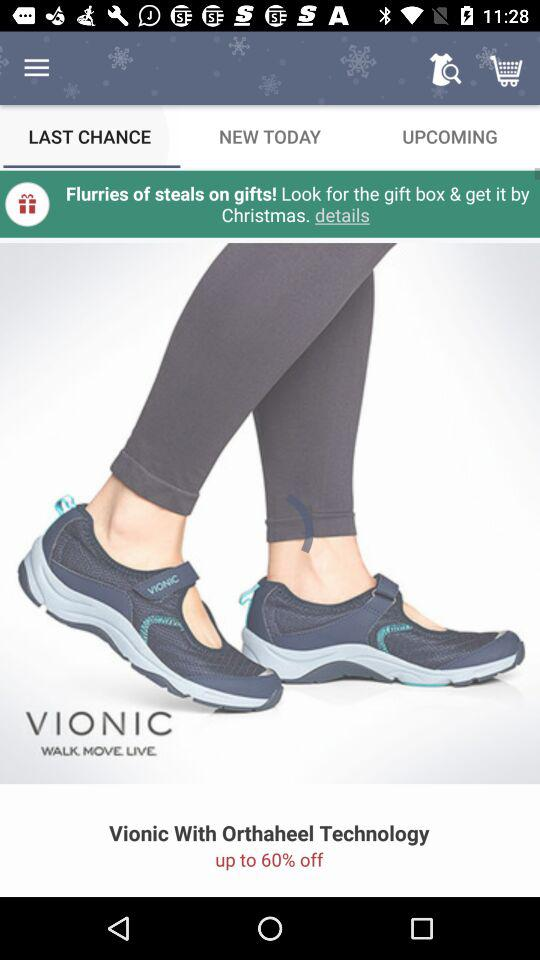What is the percentage discount on the Vionic sandal?
Answer the question using a single word or phrase. 60% 